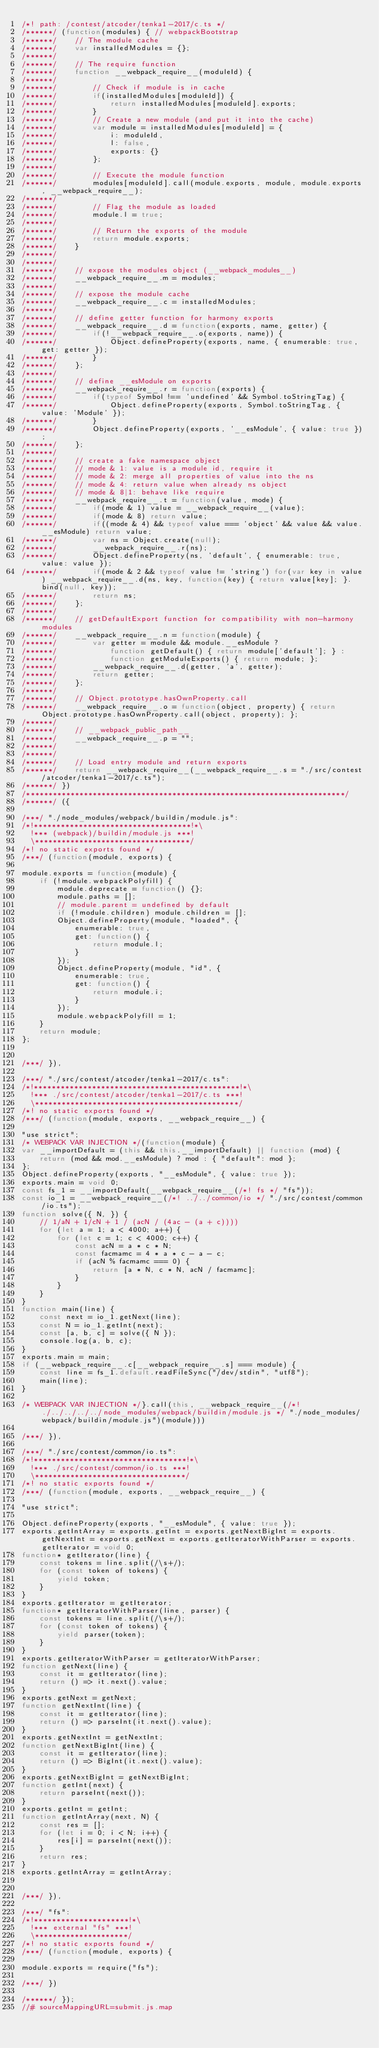Convert code to text. <code><loc_0><loc_0><loc_500><loc_500><_JavaScript_>/*! path: /contest/atcoder/tenka1-2017/c.ts */
/******/ (function(modules) { // webpackBootstrap
/******/ 	// The module cache
/******/ 	var installedModules = {};
/******/
/******/ 	// The require function
/******/ 	function __webpack_require__(moduleId) {
/******/
/******/ 		// Check if module is in cache
/******/ 		if(installedModules[moduleId]) {
/******/ 			return installedModules[moduleId].exports;
/******/ 		}
/******/ 		// Create a new module (and put it into the cache)
/******/ 		var module = installedModules[moduleId] = {
/******/ 			i: moduleId,
/******/ 			l: false,
/******/ 			exports: {}
/******/ 		};
/******/
/******/ 		// Execute the module function
/******/ 		modules[moduleId].call(module.exports, module, module.exports, __webpack_require__);
/******/
/******/ 		// Flag the module as loaded
/******/ 		module.l = true;
/******/
/******/ 		// Return the exports of the module
/******/ 		return module.exports;
/******/ 	}
/******/
/******/
/******/ 	// expose the modules object (__webpack_modules__)
/******/ 	__webpack_require__.m = modules;
/******/
/******/ 	// expose the module cache
/******/ 	__webpack_require__.c = installedModules;
/******/
/******/ 	// define getter function for harmony exports
/******/ 	__webpack_require__.d = function(exports, name, getter) {
/******/ 		if(!__webpack_require__.o(exports, name)) {
/******/ 			Object.defineProperty(exports, name, { enumerable: true, get: getter });
/******/ 		}
/******/ 	};
/******/
/******/ 	// define __esModule on exports
/******/ 	__webpack_require__.r = function(exports) {
/******/ 		if(typeof Symbol !== 'undefined' && Symbol.toStringTag) {
/******/ 			Object.defineProperty(exports, Symbol.toStringTag, { value: 'Module' });
/******/ 		}
/******/ 		Object.defineProperty(exports, '__esModule', { value: true });
/******/ 	};
/******/
/******/ 	// create a fake namespace object
/******/ 	// mode & 1: value is a module id, require it
/******/ 	// mode & 2: merge all properties of value into the ns
/******/ 	// mode & 4: return value when already ns object
/******/ 	// mode & 8|1: behave like require
/******/ 	__webpack_require__.t = function(value, mode) {
/******/ 		if(mode & 1) value = __webpack_require__(value);
/******/ 		if(mode & 8) return value;
/******/ 		if((mode & 4) && typeof value === 'object' && value && value.__esModule) return value;
/******/ 		var ns = Object.create(null);
/******/ 		__webpack_require__.r(ns);
/******/ 		Object.defineProperty(ns, 'default', { enumerable: true, value: value });
/******/ 		if(mode & 2 && typeof value != 'string') for(var key in value) __webpack_require__.d(ns, key, function(key) { return value[key]; }.bind(null, key));
/******/ 		return ns;
/******/ 	};
/******/
/******/ 	// getDefaultExport function for compatibility with non-harmony modules
/******/ 	__webpack_require__.n = function(module) {
/******/ 		var getter = module && module.__esModule ?
/******/ 			function getDefault() { return module['default']; } :
/******/ 			function getModuleExports() { return module; };
/******/ 		__webpack_require__.d(getter, 'a', getter);
/******/ 		return getter;
/******/ 	};
/******/
/******/ 	// Object.prototype.hasOwnProperty.call
/******/ 	__webpack_require__.o = function(object, property) { return Object.prototype.hasOwnProperty.call(object, property); };
/******/
/******/ 	// __webpack_public_path__
/******/ 	__webpack_require__.p = "";
/******/
/******/
/******/ 	// Load entry module and return exports
/******/ 	return __webpack_require__(__webpack_require__.s = "./src/contest/atcoder/tenka1-2017/c.ts");
/******/ })
/************************************************************************/
/******/ ({

/***/ "./node_modules/webpack/buildin/module.js":
/*!***********************************!*\
  !*** (webpack)/buildin/module.js ***!
  \***********************************/
/*! no static exports found */
/***/ (function(module, exports) {

module.exports = function(module) {
	if (!module.webpackPolyfill) {
		module.deprecate = function() {};
		module.paths = [];
		// module.parent = undefined by default
		if (!module.children) module.children = [];
		Object.defineProperty(module, "loaded", {
			enumerable: true,
			get: function() {
				return module.l;
			}
		});
		Object.defineProperty(module, "id", {
			enumerable: true,
			get: function() {
				return module.i;
			}
		});
		module.webpackPolyfill = 1;
	}
	return module;
};


/***/ }),

/***/ "./src/contest/atcoder/tenka1-2017/c.ts":
/*!**********************************************!*\
  !*** ./src/contest/atcoder/tenka1-2017/c.ts ***!
  \**********************************************/
/*! no static exports found */
/***/ (function(module, exports, __webpack_require__) {

"use strict";
/* WEBPACK VAR INJECTION */(function(module) {
var __importDefault = (this && this.__importDefault) || function (mod) {
    return (mod && mod.__esModule) ? mod : { "default": mod };
};
Object.defineProperty(exports, "__esModule", { value: true });
exports.main = void 0;
const fs_1 = __importDefault(__webpack_require__(/*! fs */ "fs"));
const io_1 = __webpack_require__(/*! ../../common/io */ "./src/contest/common/io.ts");
function solve({ N, }) {
    // 1/aN + 1/cN + 1 / (acN / (4ac - (a + c))))
    for (let a = 1; a < 4000; a++) {
        for (let c = 1; c < 4000; c++) {
            const acN = a * c * N;
            const facmamc = 4 * a * c - a - c;
            if (acN % facmamc === 0) {
                return [a * N, c * N, acN / facmamc];
            }
        }
    }
}
function main(line) {
    const next = io_1.getNext(line);
    const N = io_1.getInt(next);
    const [a, b, c] = solve({ N });
    console.log(a, b, c);
}
exports.main = main;
if (__webpack_require__.c[__webpack_require__.s] === module) {
    const line = fs_1.default.readFileSync("/dev/stdin", "utf8");
    main(line);
}

/* WEBPACK VAR INJECTION */}.call(this, __webpack_require__(/*! ./../../../../node_modules/webpack/buildin/module.js */ "./node_modules/webpack/buildin/module.js")(module)))

/***/ }),

/***/ "./src/contest/common/io.ts":
/*!**********************************!*\
  !*** ./src/contest/common/io.ts ***!
  \**********************************/
/*! no static exports found */
/***/ (function(module, exports, __webpack_require__) {

"use strict";

Object.defineProperty(exports, "__esModule", { value: true });
exports.getIntArray = exports.getInt = exports.getNextBigInt = exports.getNextInt = exports.getNext = exports.getIteratorWithParser = exports.getIterator = void 0;
function* getIterator(line) {
    const tokens = line.split(/\s+/);
    for (const token of tokens) {
        yield token;
    }
}
exports.getIterator = getIterator;
function* getIteratorWithParser(line, parser) {
    const tokens = line.split(/\s+/);
    for (const token of tokens) {
        yield parser(token);
    }
}
exports.getIteratorWithParser = getIteratorWithParser;
function getNext(line) {
    const it = getIterator(line);
    return () => it.next().value;
}
exports.getNext = getNext;
function getNextInt(line) {
    const it = getIterator(line);
    return () => parseInt(it.next().value);
}
exports.getNextInt = getNextInt;
function getNextBigInt(line) {
    const it = getIterator(line);
    return () => BigInt(it.next().value);
}
exports.getNextBigInt = getNextBigInt;
function getInt(next) {
    return parseInt(next());
}
exports.getInt = getInt;
function getIntArray(next, N) {
    const res = [];
    for (let i = 0; i < N; i++) {
        res[i] = parseInt(next());
    }
    return res;
}
exports.getIntArray = getIntArray;


/***/ }),

/***/ "fs":
/*!*********************!*\
  !*** external "fs" ***!
  \*********************/
/*! no static exports found */
/***/ (function(module, exports) {

module.exports = require("fs");

/***/ })

/******/ });
//# sourceMappingURL=submit.js.map</code> 